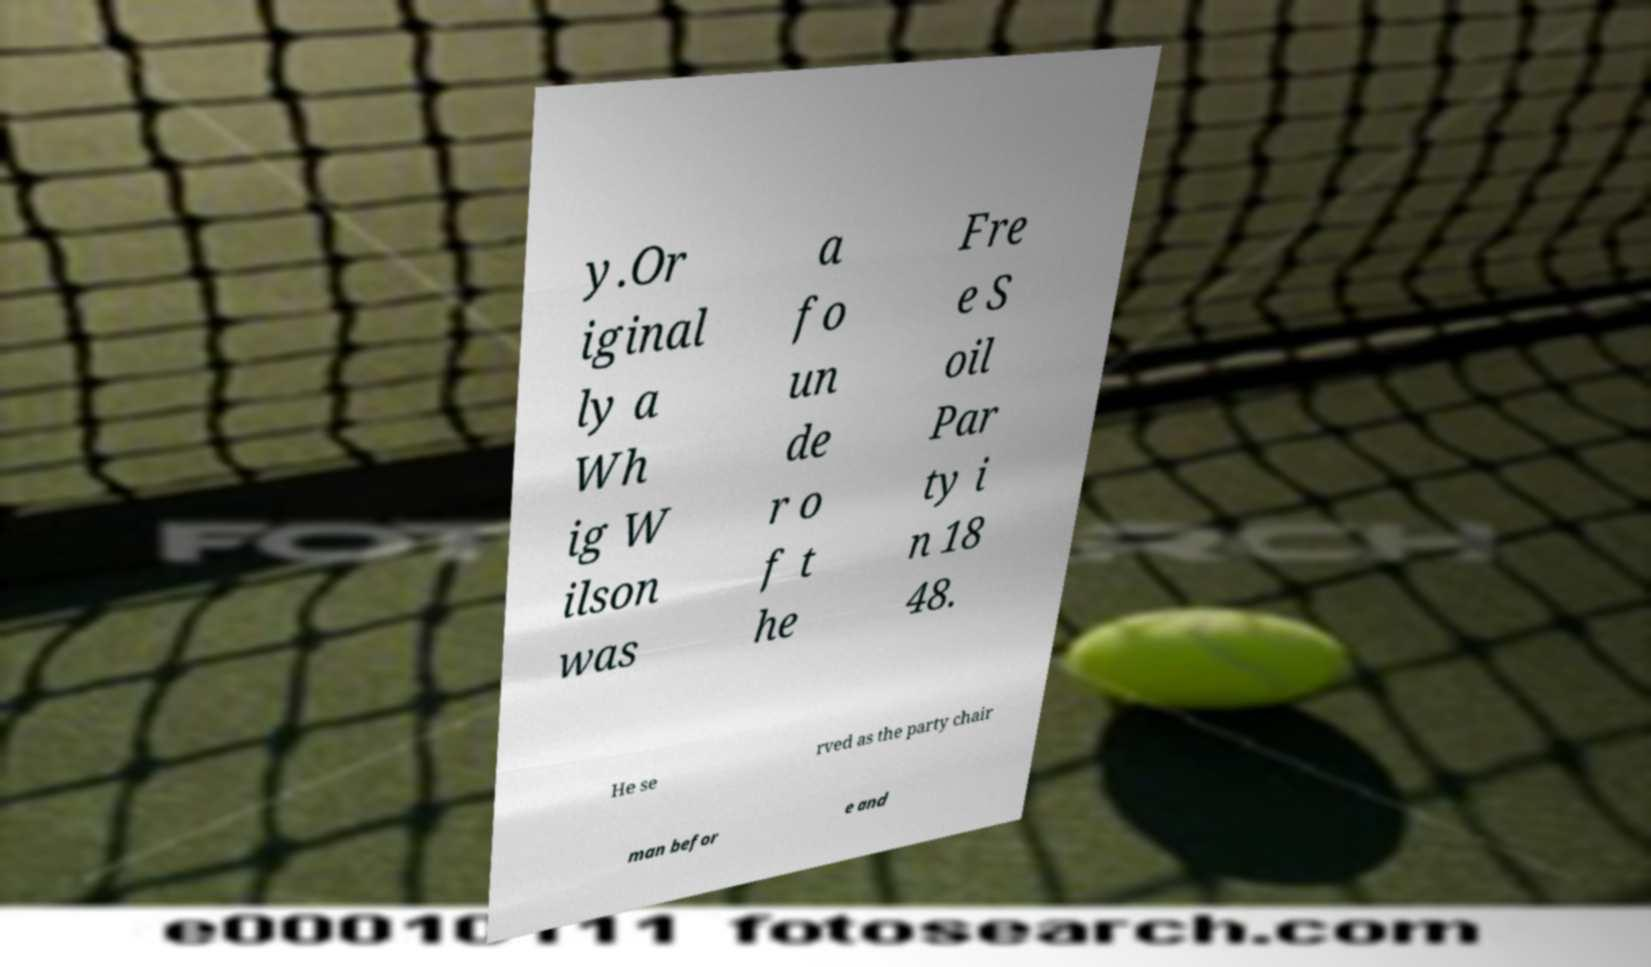There's text embedded in this image that I need extracted. Can you transcribe it verbatim? y.Or iginal ly a Wh ig W ilson was a fo un de r o f t he Fre e S oil Par ty i n 18 48. He se rved as the party chair man befor e and 